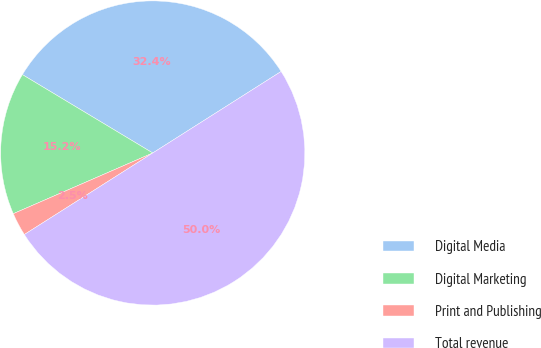Convert chart to OTSL. <chart><loc_0><loc_0><loc_500><loc_500><pie_chart><fcel>Digital Media<fcel>Digital Marketing<fcel>Print and Publishing<fcel>Total revenue<nl><fcel>32.38%<fcel>15.15%<fcel>2.47%<fcel>50.0%<nl></chart> 